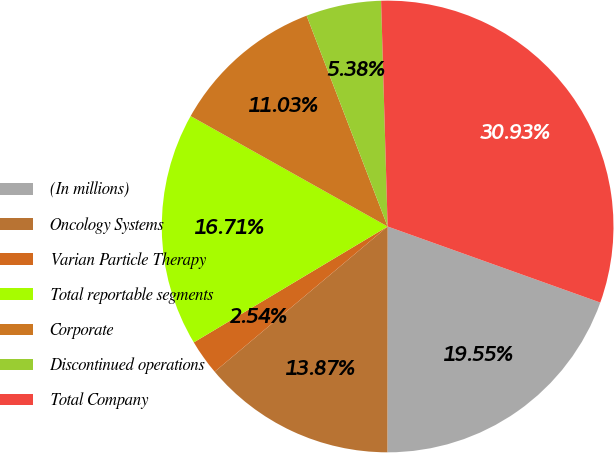<chart> <loc_0><loc_0><loc_500><loc_500><pie_chart><fcel>(In millions)<fcel>Oncology Systems<fcel>Varian Particle Therapy<fcel>Total reportable segments<fcel>Corporate<fcel>Discontinued operations<fcel>Total Company<nl><fcel>19.55%<fcel>13.87%<fcel>2.54%<fcel>16.71%<fcel>11.03%<fcel>5.38%<fcel>30.93%<nl></chart> 